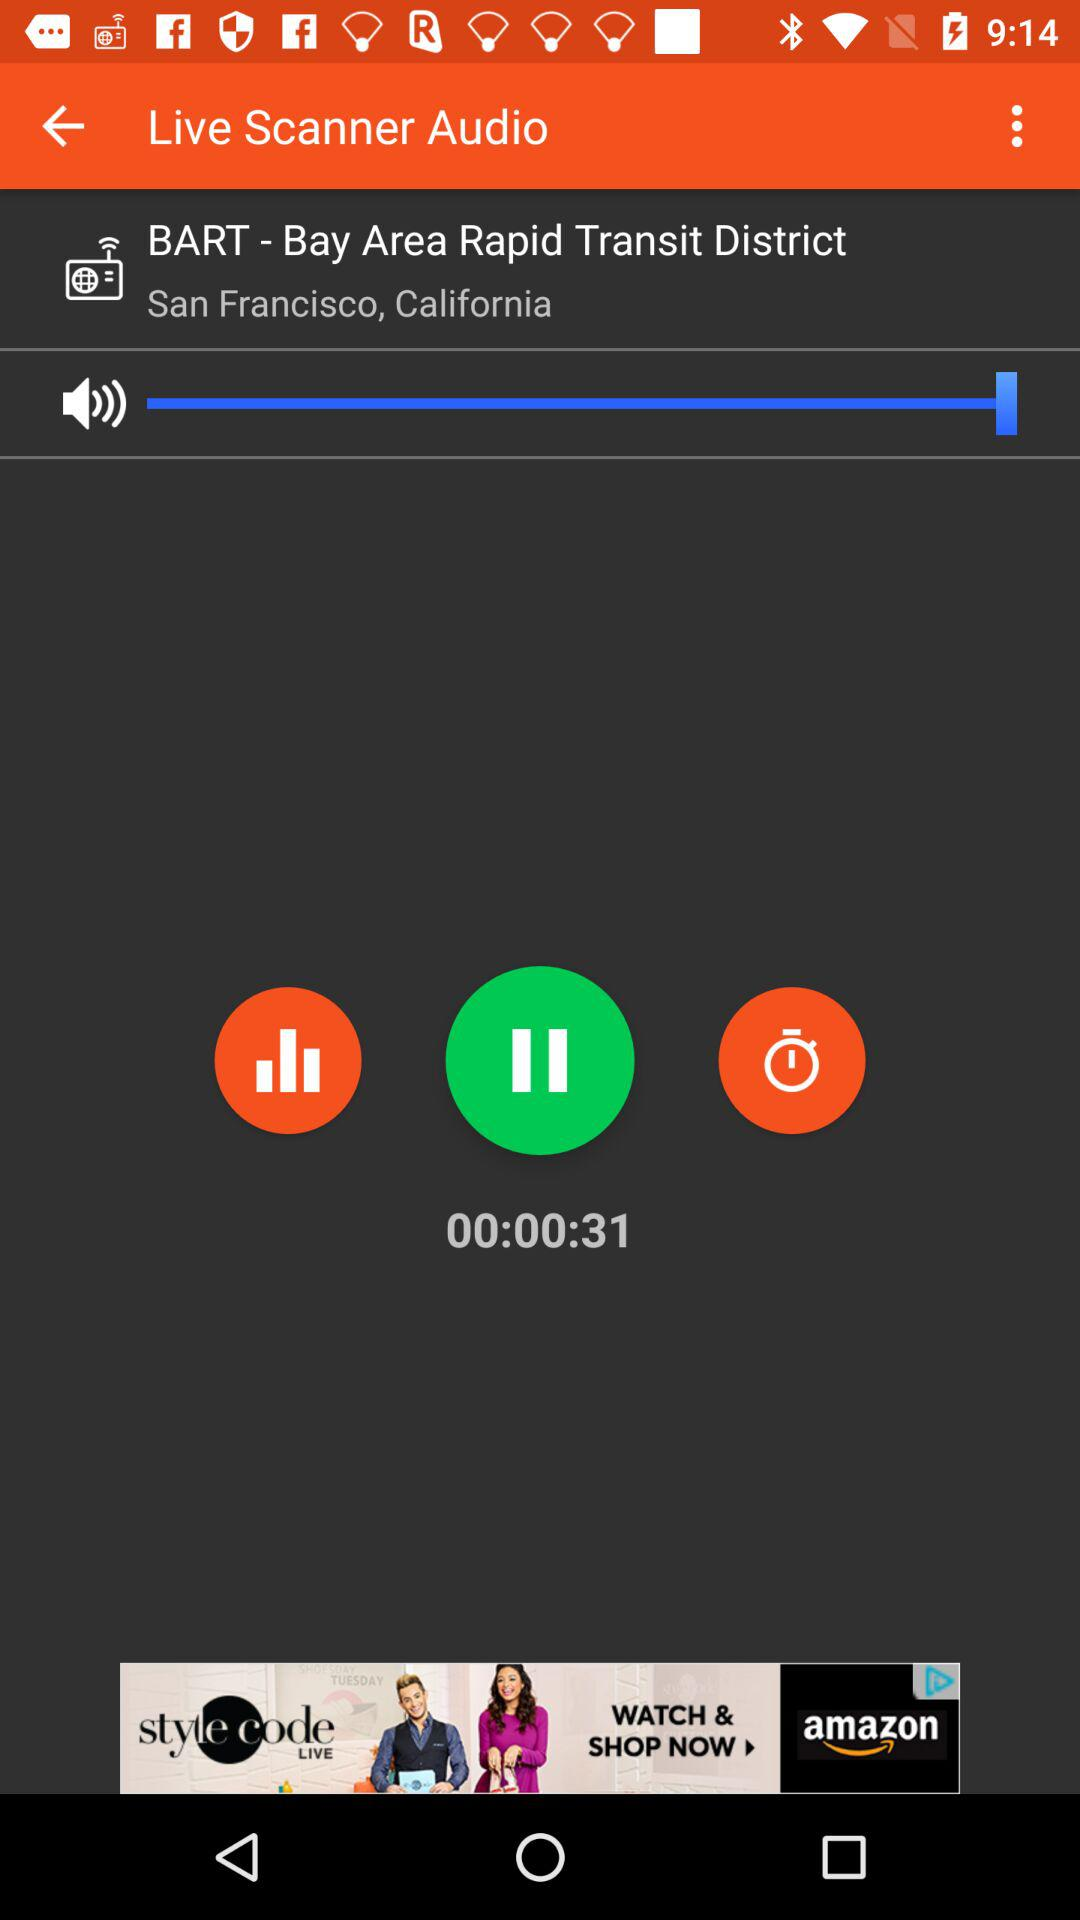What is the full form of BART? The full form of BART is Bay Area Rapid Transit. 